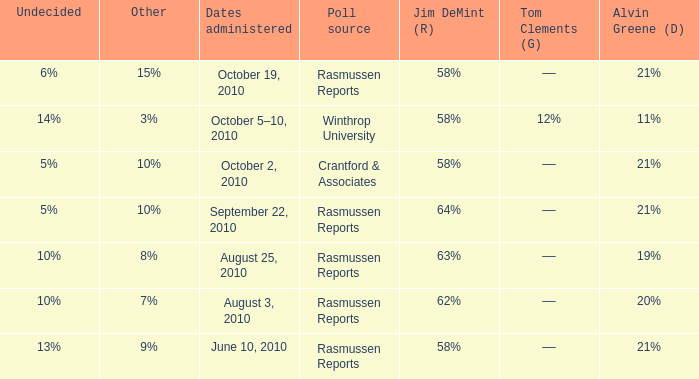What was the vote for Alvin Green when other was 9%? 21%. 